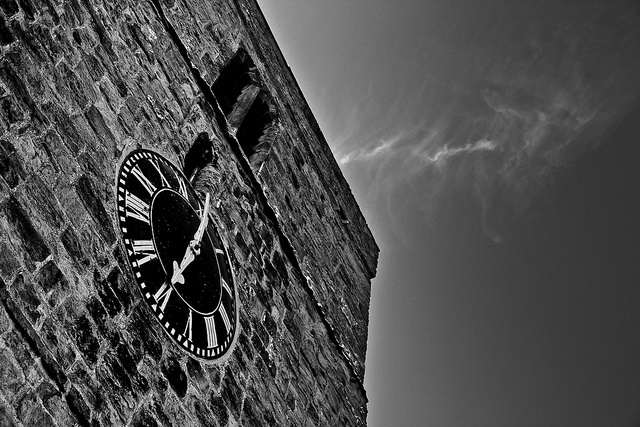Describe the objects in this image and their specific colors. I can see a clock in black, lightgray, darkgray, and gray tones in this image. 